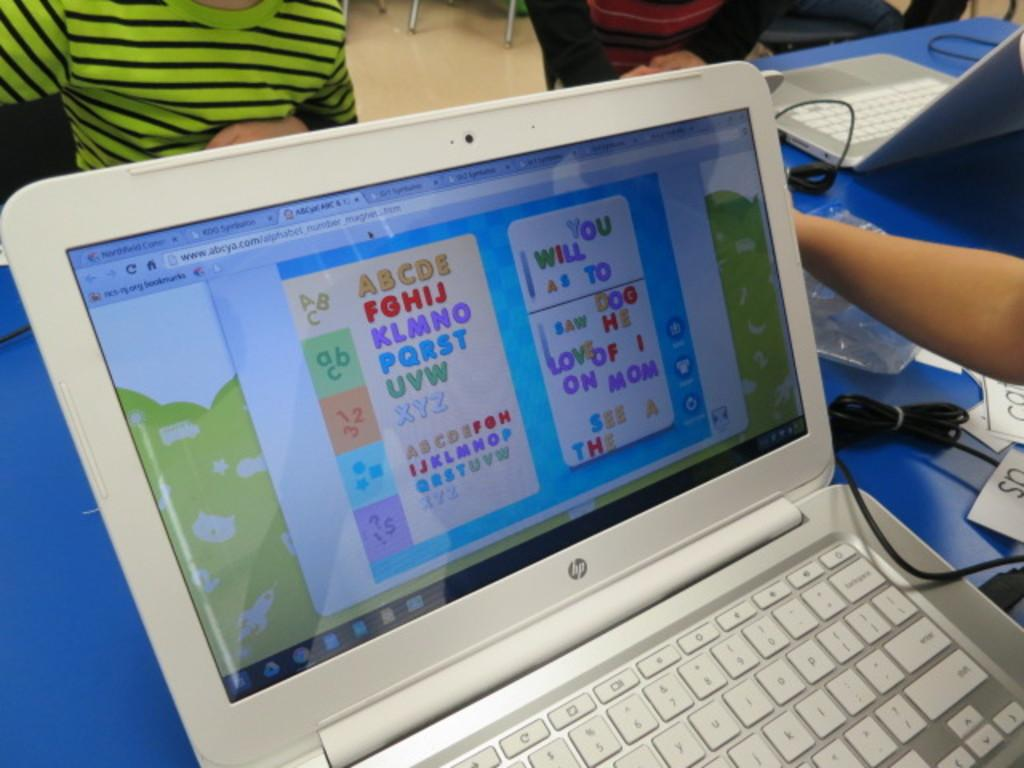<image>
Summarize the visual content of the image. An HP laptop displaying the alphabet on a desk 